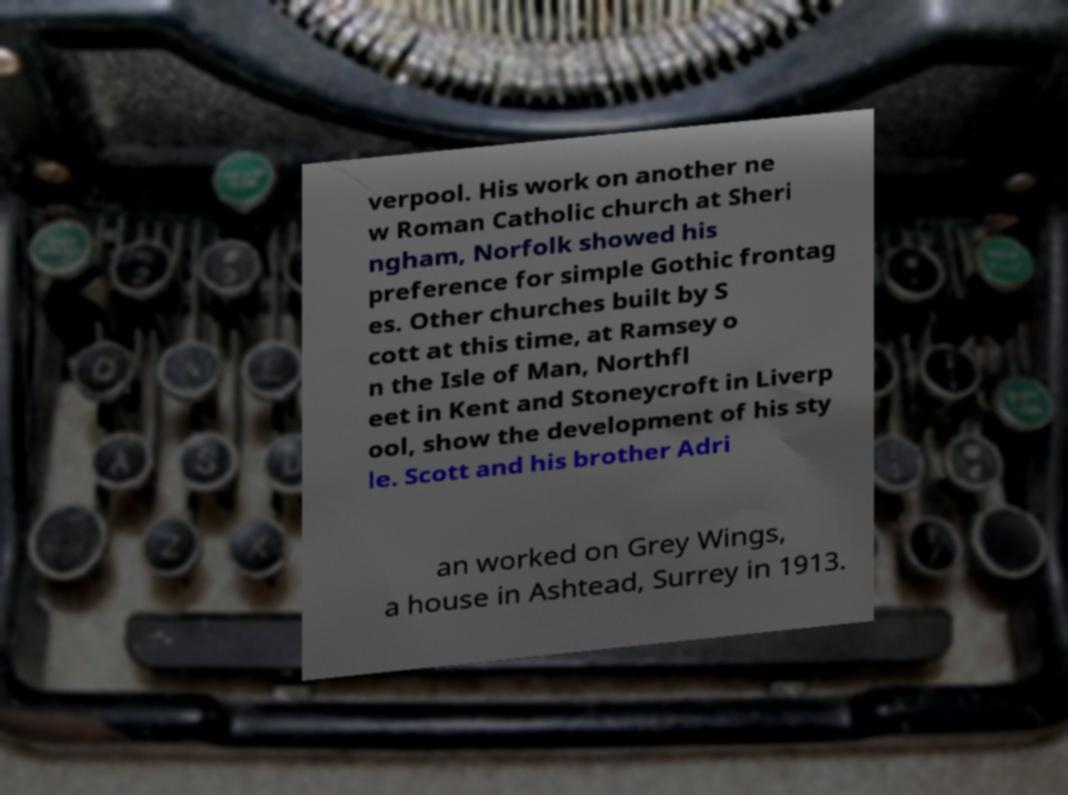There's text embedded in this image that I need extracted. Can you transcribe it verbatim? verpool. His work on another ne w Roman Catholic church at Sheri ngham, Norfolk showed his preference for simple Gothic frontag es. Other churches built by S cott at this time, at Ramsey o n the Isle of Man, Northfl eet in Kent and Stoneycroft in Liverp ool, show the development of his sty le. Scott and his brother Adri an worked on Grey Wings, a house in Ashtead, Surrey in 1913. 